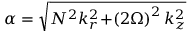<formula> <loc_0><loc_0><loc_500><loc_500>\alpha = \sqrt { N ^ { 2 } k _ { r } ^ { 2 } \, + \, \left ( 2 \Omega \right ) ^ { 2 } k _ { z } ^ { 2 } }</formula> 